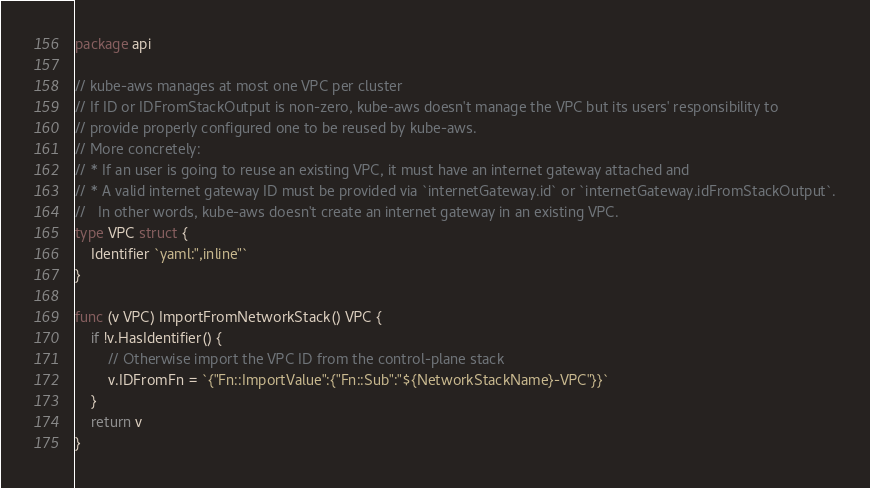<code> <loc_0><loc_0><loc_500><loc_500><_Go_>package api

// kube-aws manages at most one VPC per cluster
// If ID or IDFromStackOutput is non-zero, kube-aws doesn't manage the VPC but its users' responsibility to
// provide properly configured one to be reused by kube-aws.
// More concretely:
// * If an user is going to reuse an existing VPC, it must have an internet gateway attached and
// * A valid internet gateway ID must be provided via `internetGateway.id` or `internetGateway.idFromStackOutput`.
//   In other words, kube-aws doesn't create an internet gateway in an existing VPC.
type VPC struct {
	Identifier `yaml:",inline"`
}

func (v VPC) ImportFromNetworkStack() VPC {
	if !v.HasIdentifier() {
		// Otherwise import the VPC ID from the control-plane stack
		v.IDFromFn = `{"Fn::ImportValue":{"Fn::Sub":"${NetworkStackName}-VPC"}}`
	}
	return v
}
</code> 